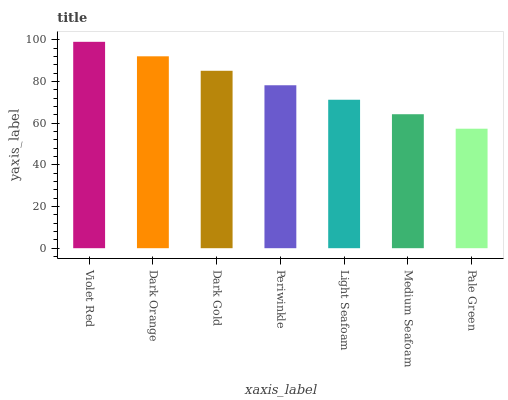Is Pale Green the minimum?
Answer yes or no. Yes. Is Violet Red the maximum?
Answer yes or no. Yes. Is Dark Orange the minimum?
Answer yes or no. No. Is Dark Orange the maximum?
Answer yes or no. No. Is Violet Red greater than Dark Orange?
Answer yes or no. Yes. Is Dark Orange less than Violet Red?
Answer yes or no. Yes. Is Dark Orange greater than Violet Red?
Answer yes or no. No. Is Violet Red less than Dark Orange?
Answer yes or no. No. Is Periwinkle the high median?
Answer yes or no. Yes. Is Periwinkle the low median?
Answer yes or no. Yes. Is Dark Orange the high median?
Answer yes or no. No. Is Light Seafoam the low median?
Answer yes or no. No. 